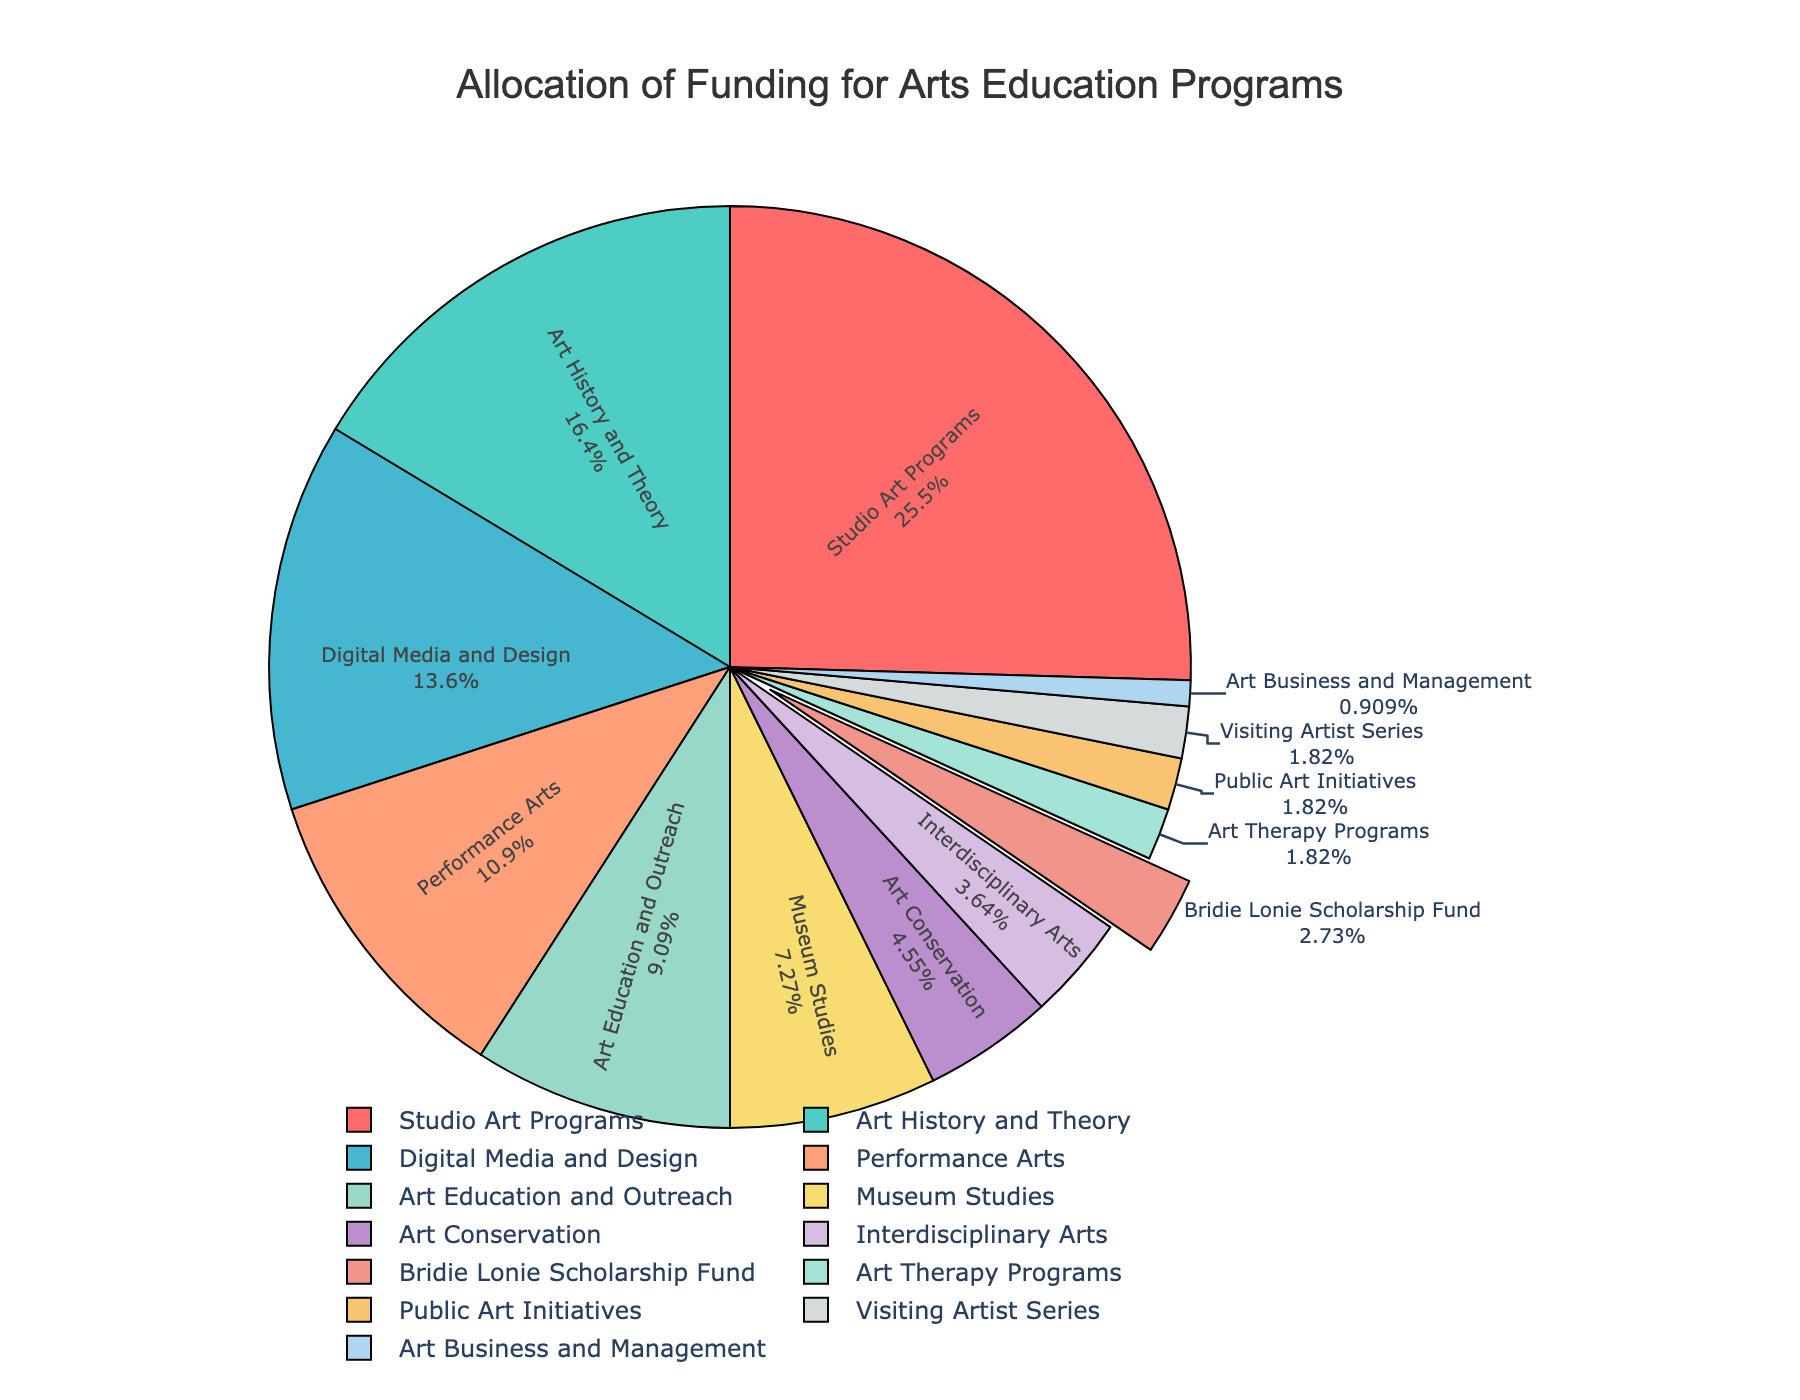What percentage of the funding is allocated to Studio Art Programs? The figure shows each category's funding percentage. Locate "Studio Art Programs" in the pie chart and read its corresponding percentage.
Answer: 28% Which program receives the second-highest percentage of funding? Identify the segments in the pie chart, and determine which category has the highest and then the second-highest percentage. "Studio Art Programs" is the highest, so find the next largest segment.
Answer: Art History and Theory What is the combined percentage of funding for Performance Arts and Digital Media and Design? Locate the segments for "Performance Arts" and "Digital Media and Design" and sum their percentages: 12% + 15%.
Answer: 27% Is the percentage of funding for the Bridie Lonie Scholarship Fund greater than that for Interdisciplinary Arts? Compare the two segments "Bridie Lonie Scholarship Fund" with 3% and "Interdisciplinary Arts" with 4%.
Answer: No Which category has the smallest percentage of funding? Identify the smallest segment by finding the lowest percentage, which corresponds to "Art Business and Management" with 1%.
Answer: Art Business and Management How much higher is the funding percentage for Studio Art Programs compared to Art Education and Outreach? Subtract the percentage of "Art Education and Outreach" from "Studio Art Programs": 28% - 10%.
Answer: 18% What is the total percentage of funding allocated to categories receiving less than 5% each? Add the percentages of "Art Conservation" (5%), "Interdisciplinary Arts" (4%), "Bridie Lonie Scholarship Fund" (3%), "Art Therapy Programs" (2%), "Public Art Initiatives" (2%), "Visiting Artist Series" (2%), and "Art Business and Management" (1%): 5% + 4% + 3% + 2% + 2% + 2% + 1%.
Answer: 19% How does the percentage of funding for Museum Studies compare to that for Art Education and Outreach? Compare the percentages of "Museum Studies" (8%) and "Art Education and Outreach" (10%).
Answer: Less Which segment representing a funding category is indicated with a distinct "pull" from the chart’s center? Identify the only segment that is separated from the rest of the pie chart, which is for the "Bridie Lonie Scholarship Fund".
Answer: Bridie Lonie Scholarship Fund 